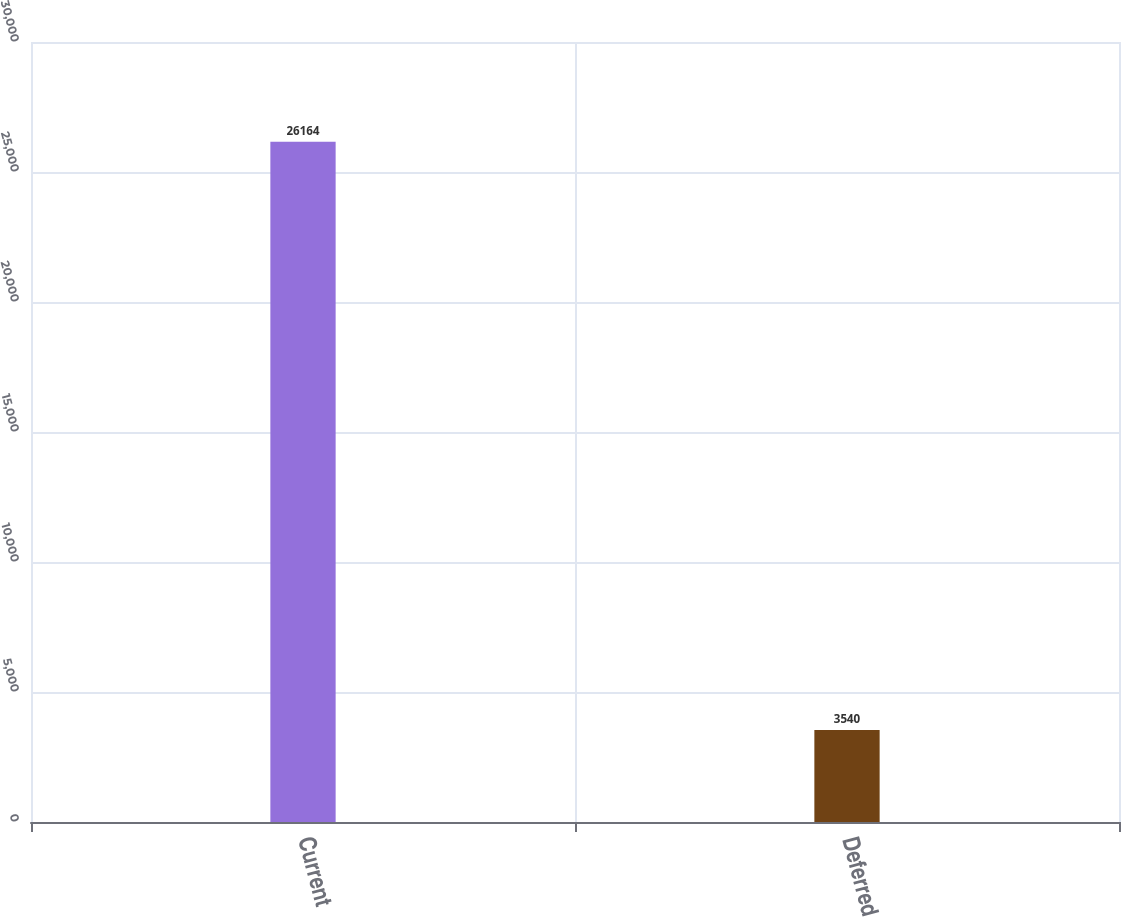Convert chart. <chart><loc_0><loc_0><loc_500><loc_500><bar_chart><fcel>Current<fcel>Deferred<nl><fcel>26164<fcel>3540<nl></chart> 